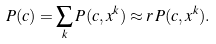Convert formula to latex. <formula><loc_0><loc_0><loc_500><loc_500>P ( c ) = \sum _ { k } P ( c , x ^ { k } ) \approx r \, P ( c , x ^ { k } ) .</formula> 